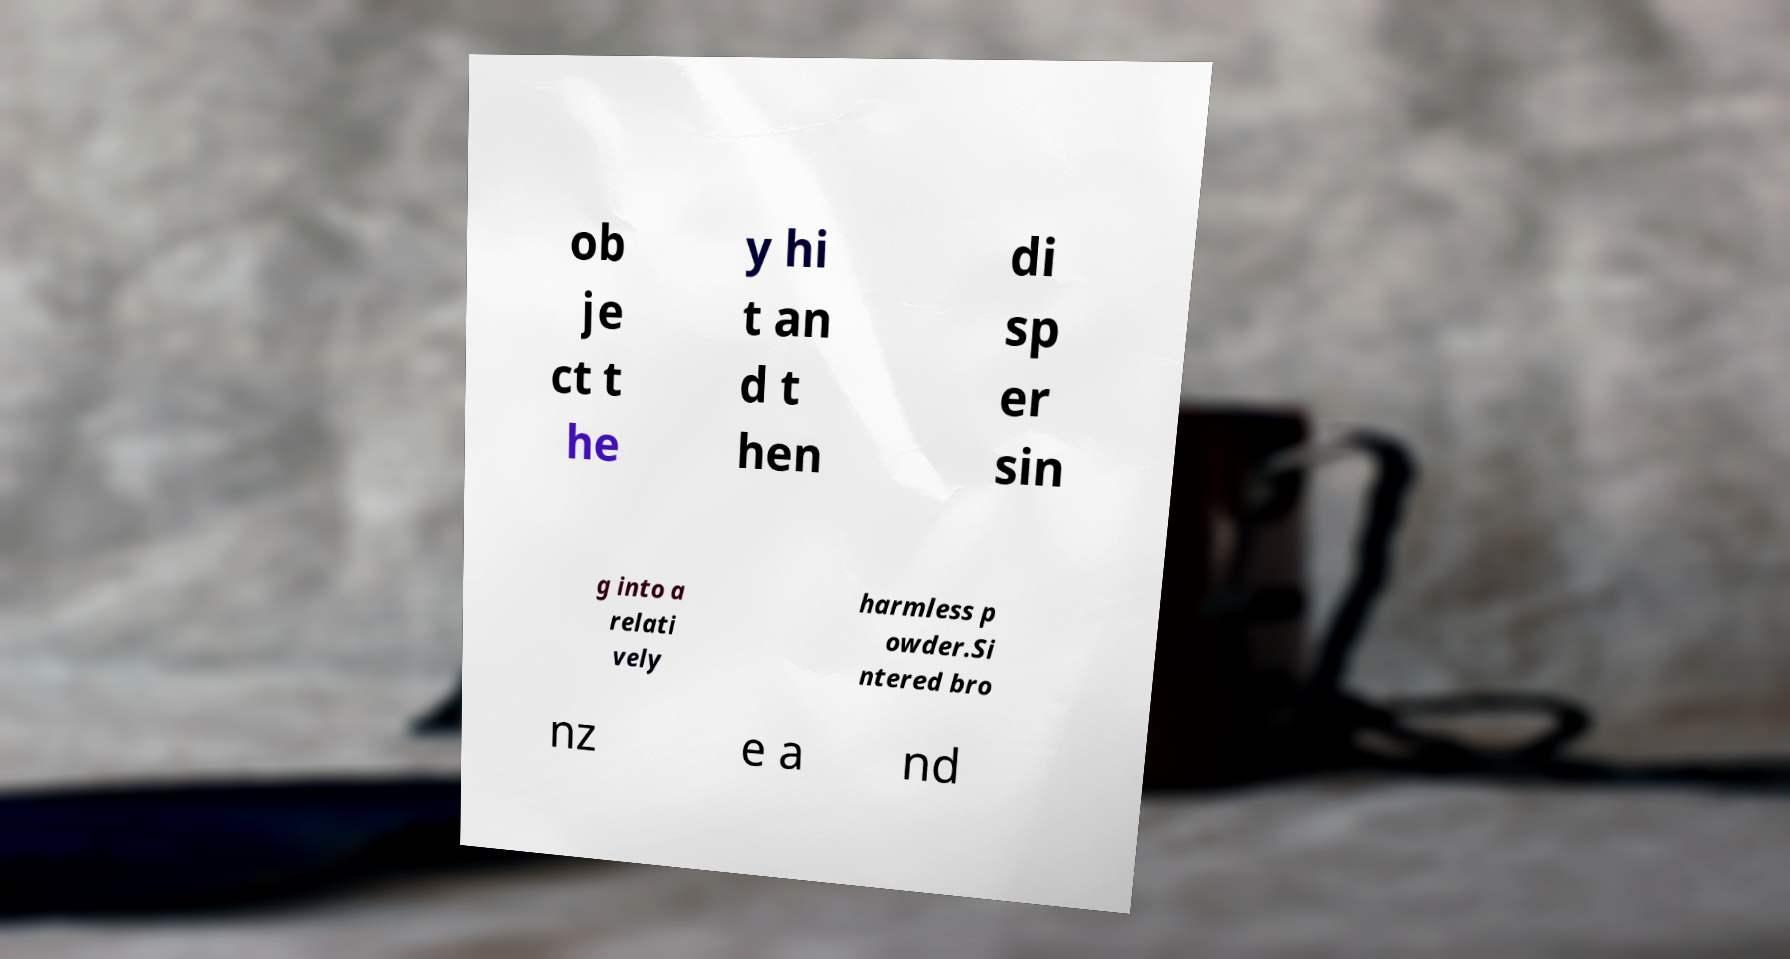There's text embedded in this image that I need extracted. Can you transcribe it verbatim? ob je ct t he y hi t an d t hen di sp er sin g into a relati vely harmless p owder.Si ntered bro nz e a nd 